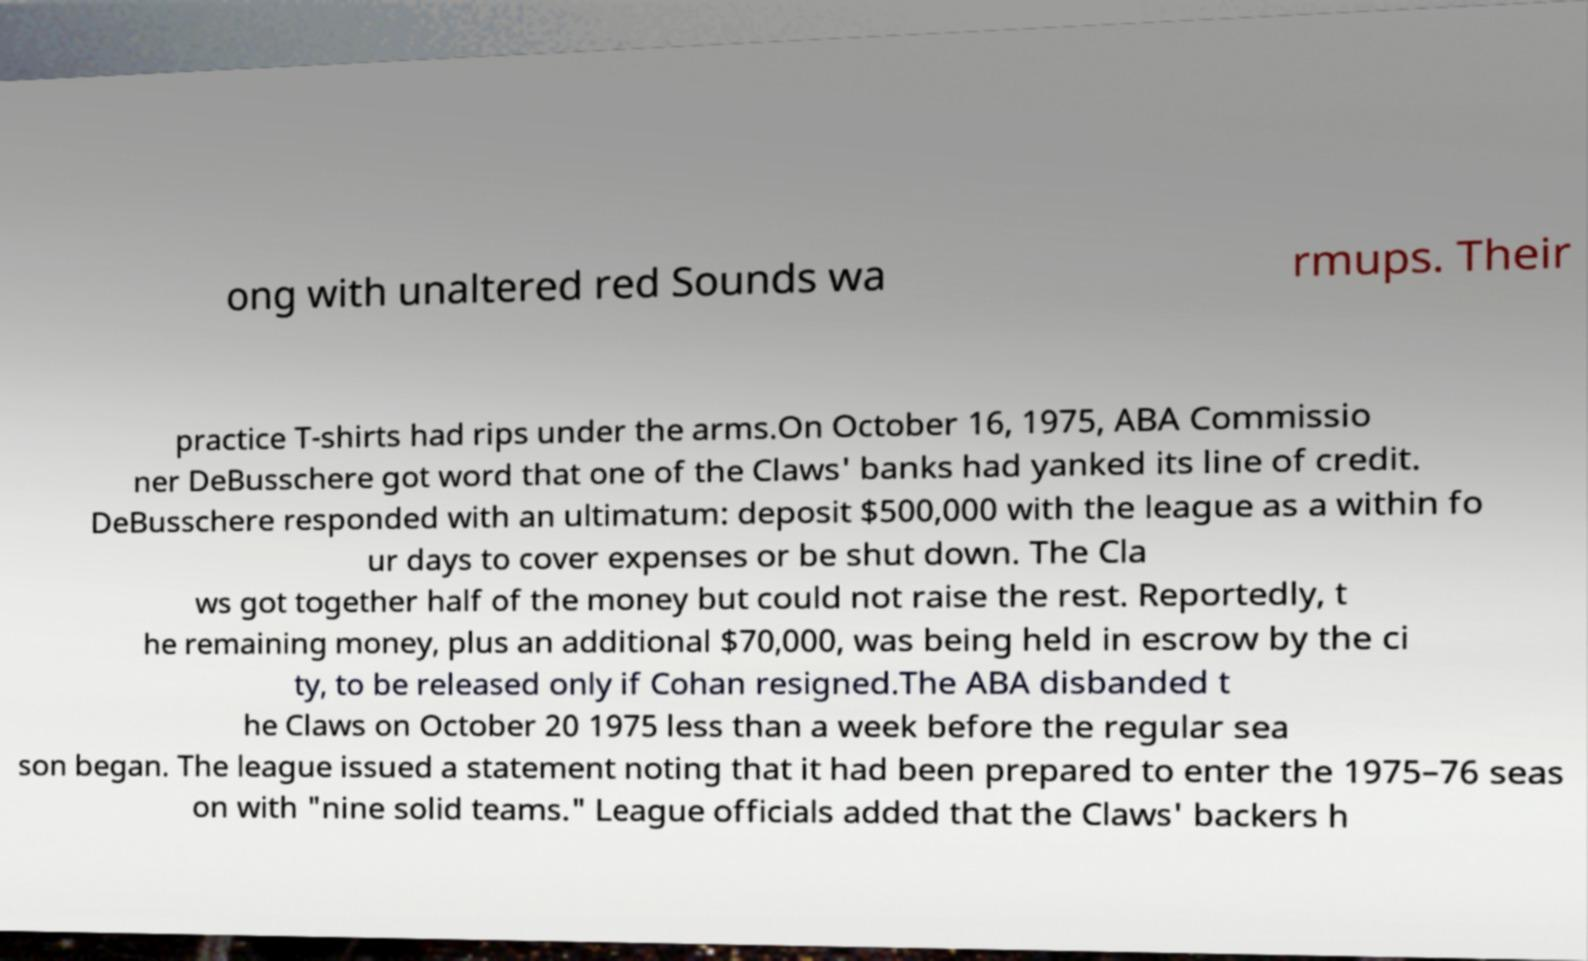What messages or text are displayed in this image? I need them in a readable, typed format. ong with unaltered red Sounds wa rmups. Their practice T-shirts had rips under the arms.On October 16, 1975, ABA Commissio ner DeBusschere got word that one of the Claws' banks had yanked its line of credit. DeBusschere responded with an ultimatum: deposit $500,000 with the league as a within fo ur days to cover expenses or be shut down. The Cla ws got together half of the money but could not raise the rest. Reportedly, t he remaining money, plus an additional $70,000, was being held in escrow by the ci ty, to be released only if Cohan resigned.The ABA disbanded t he Claws on October 20 1975 less than a week before the regular sea son began. The league issued a statement noting that it had been prepared to enter the 1975–76 seas on with "nine solid teams." League officials added that the Claws' backers h 